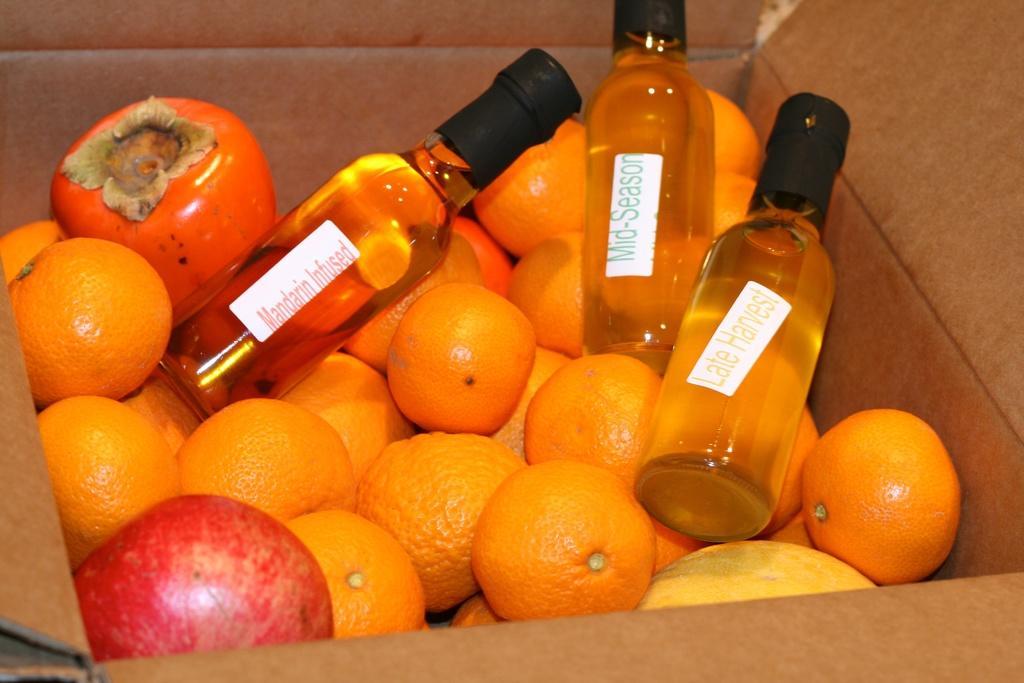Could you give a brief overview of what you see in this image? In this image there is a cardboard box with many oranges, a few pomegranates and three bottles with labels on them in the box. 